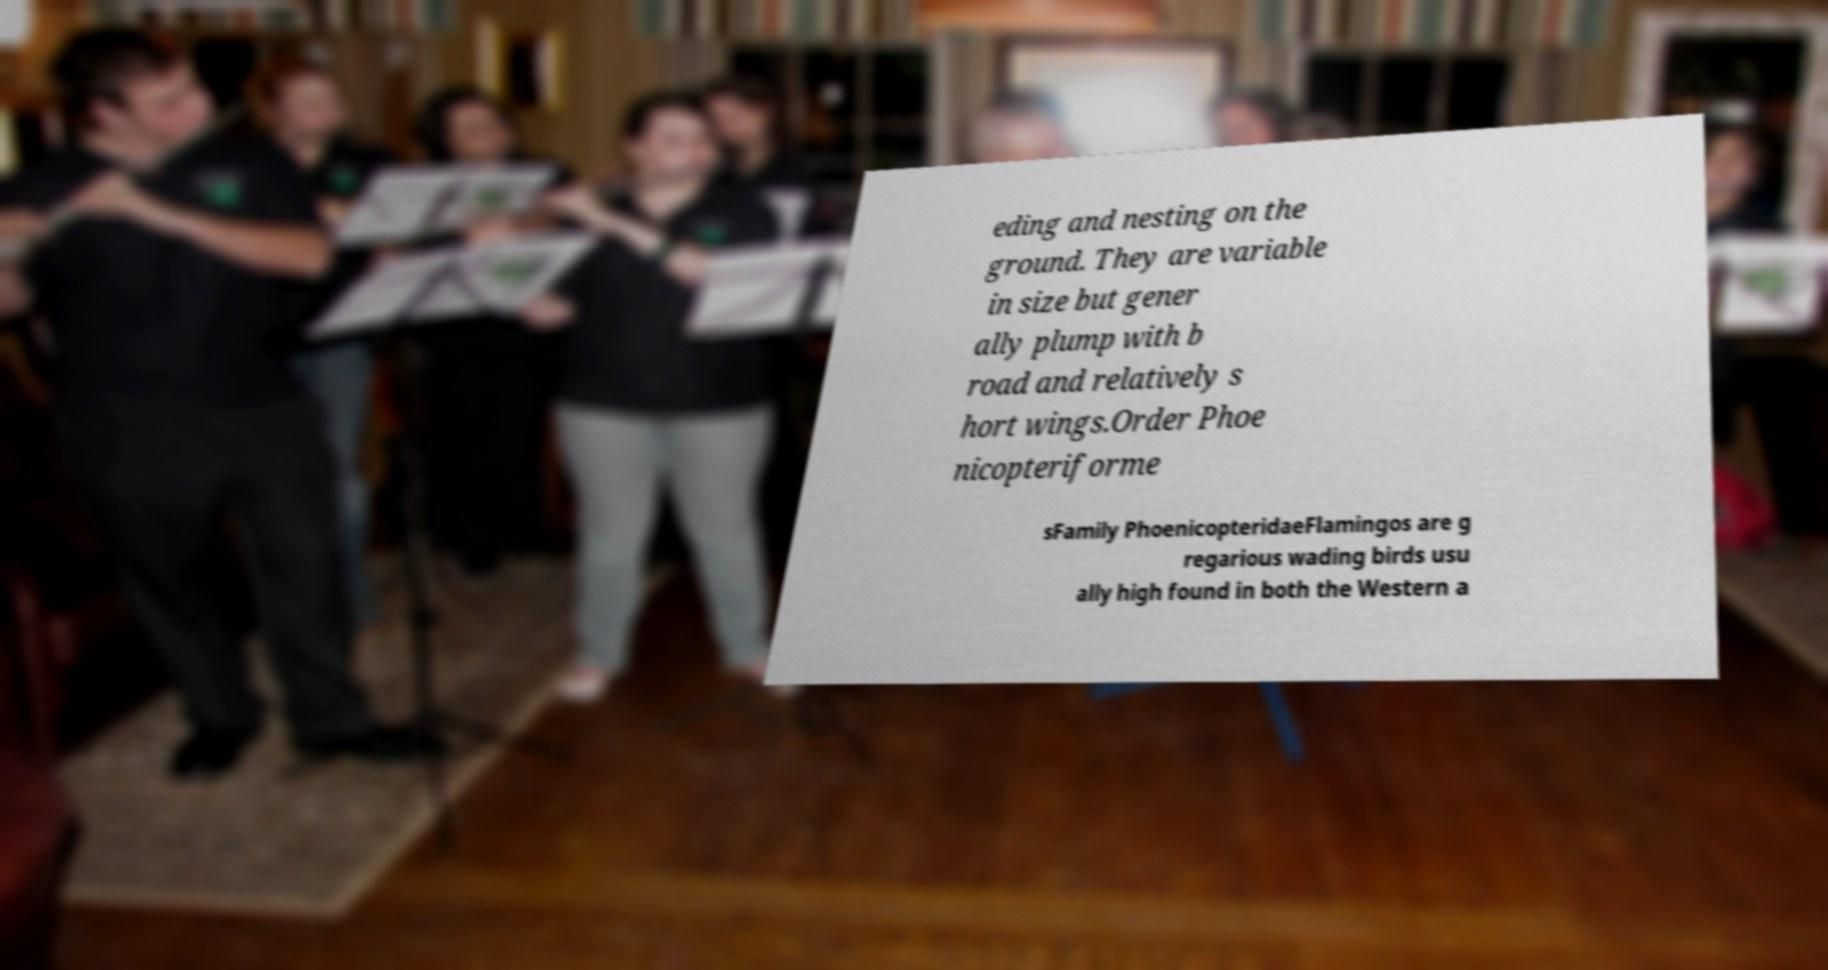Please identify and transcribe the text found in this image. eding and nesting on the ground. They are variable in size but gener ally plump with b road and relatively s hort wings.Order Phoe nicopteriforme sFamily PhoenicopteridaeFlamingos are g regarious wading birds usu ally high found in both the Western a 